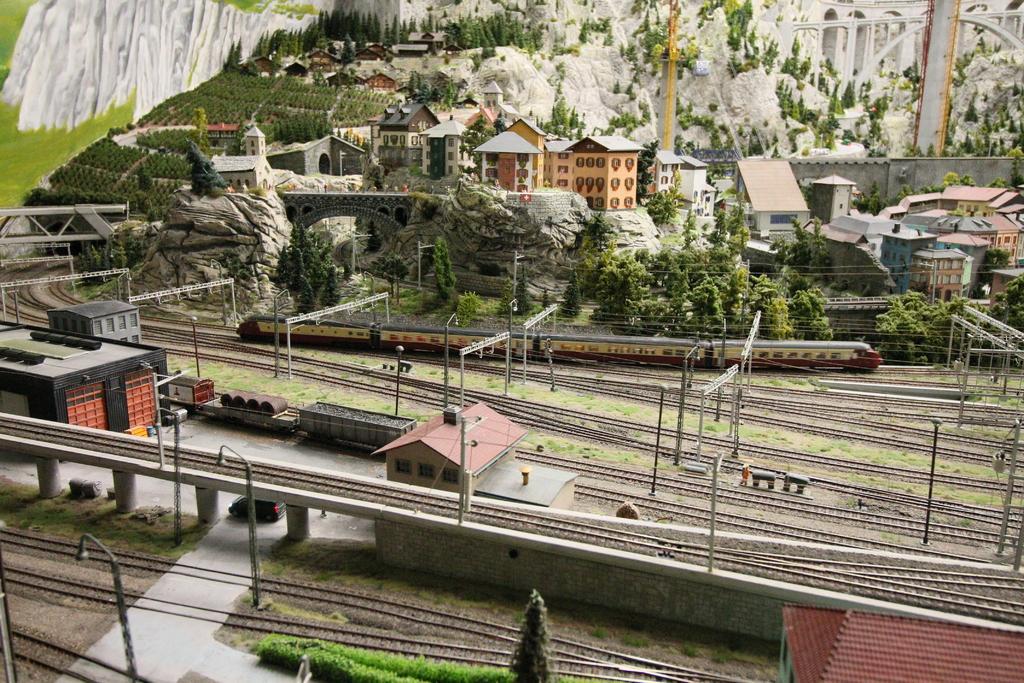In one or two sentences, can you explain what this image depicts? In this picture we can see railway tracks, poles, plants, train, trees, and houses. In the background there is a mountain. 